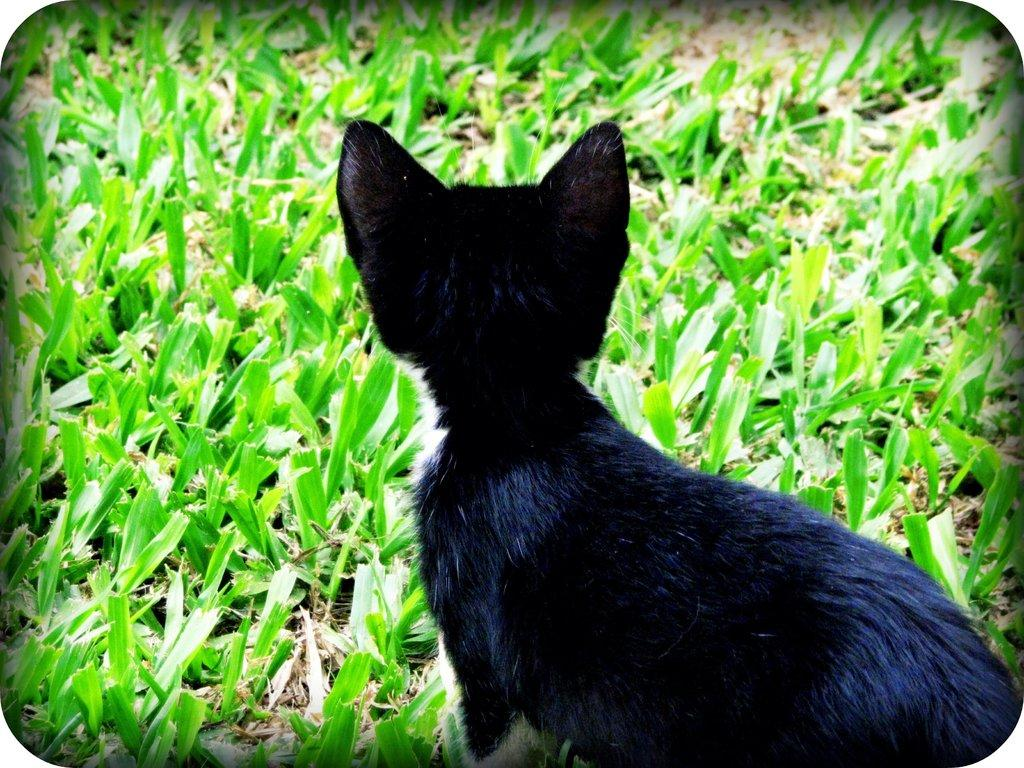What type of terrain is visible in the image? There is a grassy land in the image. What other living creature can be seen in the image? There is an animal in the image. What is the color of the animal in the image? The animal is black in color. What type of respect can be seen being exchanged between the animal and the grass in the image? There is no indication of respect being exchanged between the animal and the grass in the image. How does the animal maintain its grip on the grass in the image? There is no indication of the animal gripping the grass in the image. 